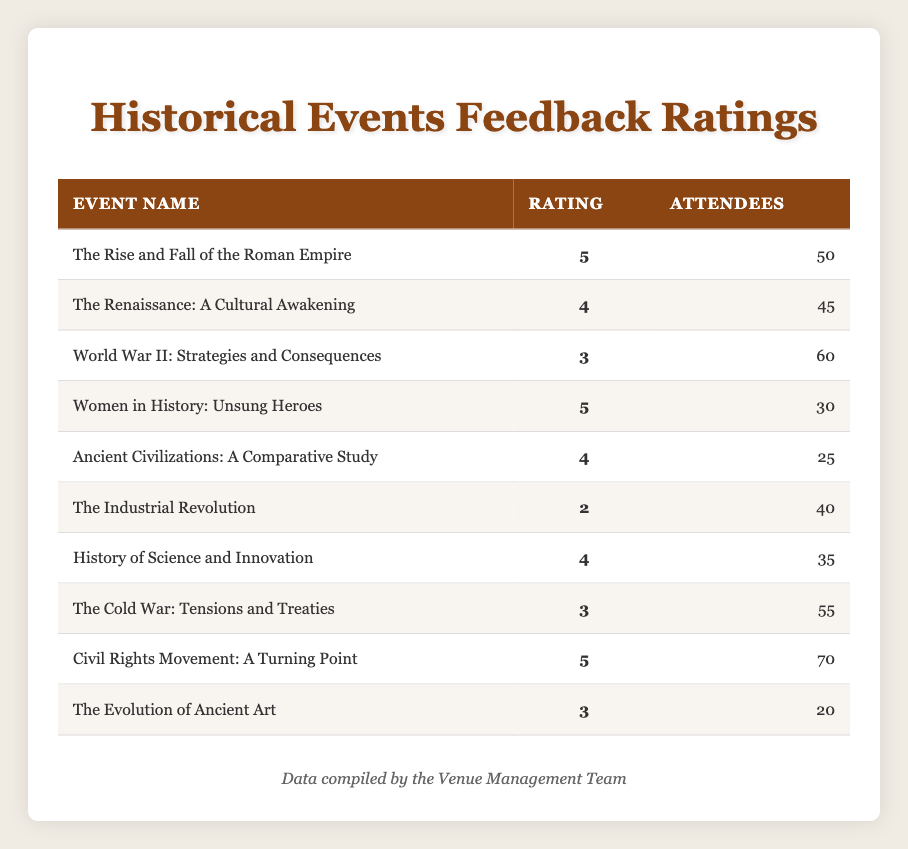What is the highest feedback rating for an event? The table lists various events with their corresponding feedback ratings. The highest rating is 5 for "The Rise and Fall of the Roman Empire," "Women in History: Unsung Heroes," and "Civil Rights Movement: A Turning Point." Therefore, the highest feedback rating is 5.
Answer: 5 How many attendees participated in "The Industrial Revolution" event? Referring to the table, the event "The Industrial Revolution" shows that there were 40 attendees.
Answer: 40 What is the average rating of the events organized at the venue? To calculate the average, we sum the ratings: (5 + 4 + 3 + 5 + 4 + 2 + 4 + 3 + 5 + 3) = 38. Then, we divide by the total number of events, which is 10. So, the average rating is 38/10 = 3.8.
Answer: 3.8 Did more people attend the "Civil Rights Movement: A Turning Point" event compared to "The Renaissance: A Cultural Awakening"? "Civil Rights Movement: A Turning Point" had 70 attendees, while "The Renaissance: A Cultural Awakening" had 45 attendees. Since 70 is greater than 45, more people attended the former event.
Answer: Yes What is the total number of attendees for events that received a rating of 4? The events with a rating of 4 are "The Renaissance: A Cultural Awakening," "Ancient Civilizations: A Comparative Study," and "History of Science and Innovation," with 45, 25, and 35 attendees respectively. The total is 45 + 25 + 35 = 105.
Answer: 105 Which event had the lowest rating, and how many attendees were there for that event? The event with the lowest rating is "The Industrial Revolution," which has a rating of 2 and 40 attendees.
Answer: The Industrial Revolution, 40 How many events received a rating lower than 4? In the table, there are three events rated below 4: "World War II: Strategies and Consequences" (3), "The Industrial Revolution" (2), and "The Cold War: Tensions and Treaties" (3). Thus, there are three events rated lower than 4.
Answer: 3 Among the events with a rating of 3, which one had the most attendees? The events with a rating of 3 are "World War II: Strategies and Consequences" (60 attendees), "The Cold War: Tensions and Treaties" (55 attendees), and "The Evolution of Ancient Art" (20 attendees). Among these, "World War II: Strategies and Consequences" had the most attendees with 60.
Answer: World War II: Strategies and Consequences, 60 What percentage of attendees rated the "Women in History: Unsung Heroes" event with the top rating? The "Women in History: Unsung Heroes" event had 30 attendees, all giving it a rating of 5. To find the percentage, we need to consider the total number of attendees across all events, which is 50 + 45 + 60 + 30 + 25 + 40 + 35 + 55 + 70 + 20 = 430. Therefore, the percentage is (30/430) * 100 ≈ 6.98%.
Answer: Approximately 6.98% 